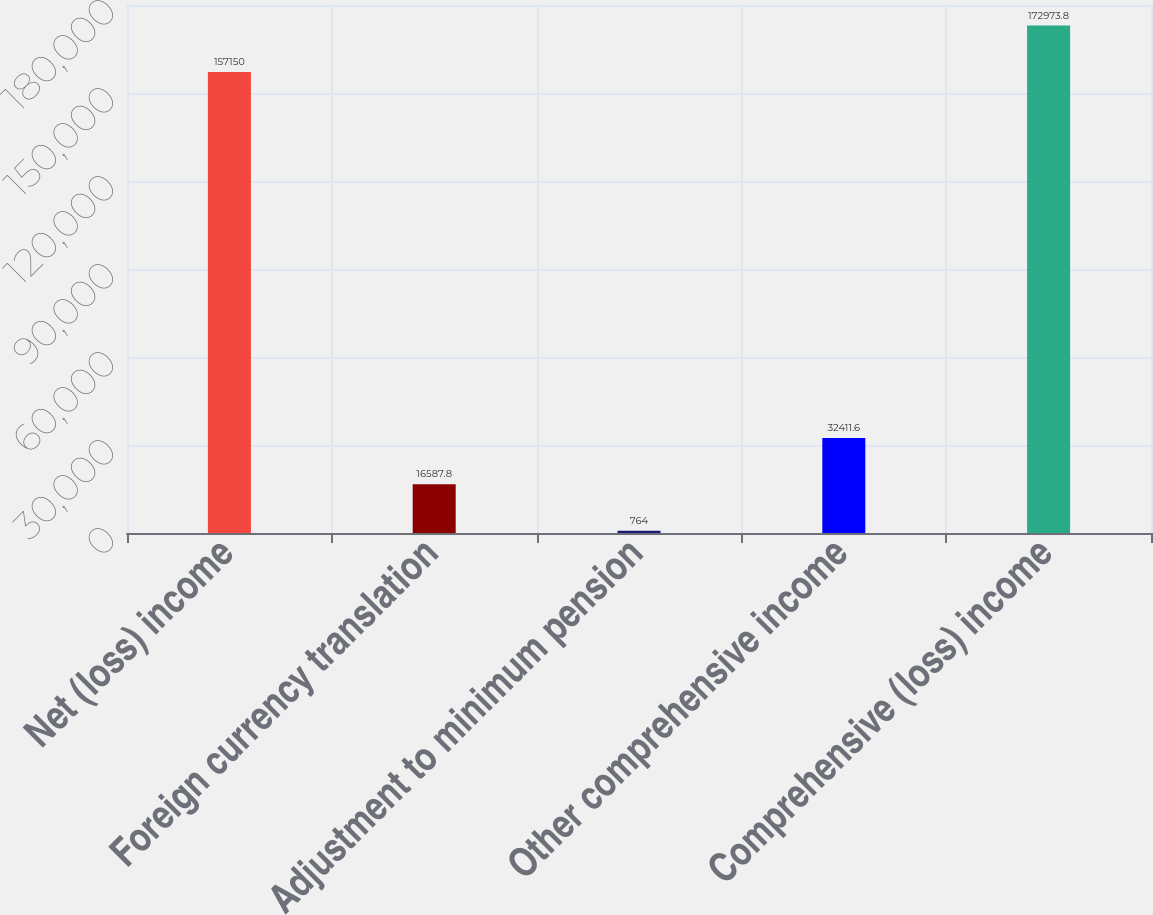Convert chart to OTSL. <chart><loc_0><loc_0><loc_500><loc_500><bar_chart><fcel>Net (loss) income<fcel>Foreign currency translation<fcel>Adjustment to minimum pension<fcel>Other comprehensive income<fcel>Comprehensive (loss) income<nl><fcel>157150<fcel>16587.8<fcel>764<fcel>32411.6<fcel>172974<nl></chart> 